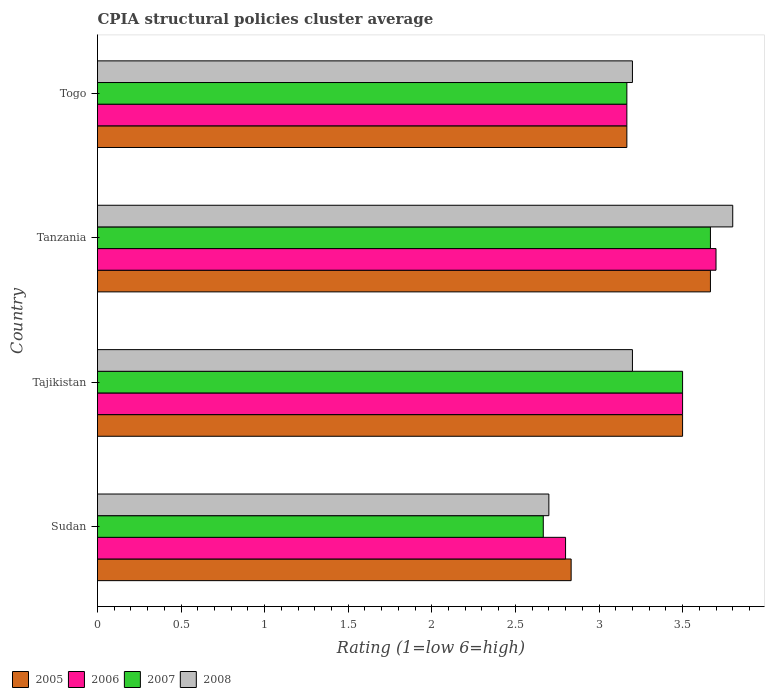How many groups of bars are there?
Ensure brevity in your answer.  4. Are the number of bars per tick equal to the number of legend labels?
Your answer should be compact. Yes. Are the number of bars on each tick of the Y-axis equal?
Your answer should be compact. Yes. What is the label of the 3rd group of bars from the top?
Provide a succinct answer. Tajikistan. In how many cases, is the number of bars for a given country not equal to the number of legend labels?
Offer a terse response. 0. Across all countries, what is the maximum CPIA rating in 2007?
Offer a terse response. 3.67. In which country was the CPIA rating in 2007 maximum?
Your answer should be compact. Tanzania. In which country was the CPIA rating in 2007 minimum?
Provide a succinct answer. Sudan. What is the total CPIA rating in 2007 in the graph?
Your answer should be very brief. 13. What is the difference between the CPIA rating in 2005 in Tajikistan and that in Tanzania?
Give a very brief answer. -0.17. What is the difference between the CPIA rating in 2008 in Togo and the CPIA rating in 2006 in Tajikistan?
Your answer should be very brief. -0.3. What is the average CPIA rating in 2008 per country?
Offer a very short reply. 3.22. What is the difference between the CPIA rating in 2006 and CPIA rating in 2008 in Sudan?
Offer a terse response. 0.1. What is the ratio of the CPIA rating in 2006 in Sudan to that in Togo?
Offer a very short reply. 0.88. Is the CPIA rating in 2008 in Sudan less than that in Tanzania?
Give a very brief answer. Yes. Is the difference between the CPIA rating in 2006 in Sudan and Tanzania greater than the difference between the CPIA rating in 2008 in Sudan and Tanzania?
Your answer should be very brief. Yes. What is the difference between the highest and the second highest CPIA rating in 2006?
Your answer should be very brief. 0.2. What is the difference between the highest and the lowest CPIA rating in 2008?
Your answer should be very brief. 1.1. Is it the case that in every country, the sum of the CPIA rating in 2008 and CPIA rating in 2007 is greater than the sum of CPIA rating in 2005 and CPIA rating in 2006?
Offer a terse response. No. What does the 1st bar from the bottom in Tanzania represents?
Your response must be concise. 2005. How many bars are there?
Your answer should be very brief. 16. Are all the bars in the graph horizontal?
Ensure brevity in your answer.  Yes. How many legend labels are there?
Offer a very short reply. 4. What is the title of the graph?
Ensure brevity in your answer.  CPIA structural policies cluster average. What is the label or title of the X-axis?
Your answer should be compact. Rating (1=low 6=high). What is the Rating (1=low 6=high) of 2005 in Sudan?
Make the answer very short. 2.83. What is the Rating (1=low 6=high) of 2006 in Sudan?
Offer a terse response. 2.8. What is the Rating (1=low 6=high) in 2007 in Sudan?
Provide a succinct answer. 2.67. What is the Rating (1=low 6=high) in 2005 in Tajikistan?
Provide a succinct answer. 3.5. What is the Rating (1=low 6=high) of 2006 in Tajikistan?
Offer a very short reply. 3.5. What is the Rating (1=low 6=high) of 2007 in Tajikistan?
Ensure brevity in your answer.  3.5. What is the Rating (1=low 6=high) of 2008 in Tajikistan?
Ensure brevity in your answer.  3.2. What is the Rating (1=low 6=high) of 2005 in Tanzania?
Make the answer very short. 3.67. What is the Rating (1=low 6=high) of 2007 in Tanzania?
Offer a very short reply. 3.67. What is the Rating (1=low 6=high) in 2005 in Togo?
Give a very brief answer. 3.17. What is the Rating (1=low 6=high) of 2006 in Togo?
Keep it short and to the point. 3.17. What is the Rating (1=low 6=high) in 2007 in Togo?
Your answer should be very brief. 3.17. Across all countries, what is the maximum Rating (1=low 6=high) in 2005?
Make the answer very short. 3.67. Across all countries, what is the maximum Rating (1=low 6=high) of 2007?
Keep it short and to the point. 3.67. Across all countries, what is the maximum Rating (1=low 6=high) of 2008?
Make the answer very short. 3.8. Across all countries, what is the minimum Rating (1=low 6=high) in 2005?
Provide a short and direct response. 2.83. Across all countries, what is the minimum Rating (1=low 6=high) in 2006?
Keep it short and to the point. 2.8. Across all countries, what is the minimum Rating (1=low 6=high) of 2007?
Provide a succinct answer. 2.67. What is the total Rating (1=low 6=high) of 2005 in the graph?
Provide a succinct answer. 13.17. What is the total Rating (1=low 6=high) in 2006 in the graph?
Your answer should be compact. 13.17. What is the total Rating (1=low 6=high) of 2007 in the graph?
Make the answer very short. 13. What is the difference between the Rating (1=low 6=high) of 2006 in Sudan and that in Tajikistan?
Make the answer very short. -0.7. What is the difference between the Rating (1=low 6=high) of 2007 in Sudan and that in Tajikistan?
Ensure brevity in your answer.  -0.83. What is the difference between the Rating (1=low 6=high) of 2005 in Sudan and that in Tanzania?
Your response must be concise. -0.83. What is the difference between the Rating (1=low 6=high) in 2007 in Sudan and that in Tanzania?
Offer a terse response. -1. What is the difference between the Rating (1=low 6=high) in 2006 in Sudan and that in Togo?
Ensure brevity in your answer.  -0.37. What is the difference between the Rating (1=low 6=high) of 2007 in Sudan and that in Togo?
Give a very brief answer. -0.5. What is the difference between the Rating (1=low 6=high) of 2005 in Tajikistan and that in Tanzania?
Your response must be concise. -0.17. What is the difference between the Rating (1=low 6=high) in 2006 in Tajikistan and that in Tanzania?
Your response must be concise. -0.2. What is the difference between the Rating (1=low 6=high) in 2007 in Tajikistan and that in Tanzania?
Your answer should be very brief. -0.17. What is the difference between the Rating (1=low 6=high) of 2005 in Tajikistan and that in Togo?
Your answer should be very brief. 0.33. What is the difference between the Rating (1=low 6=high) of 2007 in Tajikistan and that in Togo?
Keep it short and to the point. 0.33. What is the difference between the Rating (1=low 6=high) of 2008 in Tajikistan and that in Togo?
Keep it short and to the point. 0. What is the difference between the Rating (1=low 6=high) of 2006 in Tanzania and that in Togo?
Keep it short and to the point. 0.53. What is the difference between the Rating (1=low 6=high) of 2007 in Tanzania and that in Togo?
Your response must be concise. 0.5. What is the difference between the Rating (1=low 6=high) of 2008 in Tanzania and that in Togo?
Your answer should be very brief. 0.6. What is the difference between the Rating (1=low 6=high) of 2005 in Sudan and the Rating (1=low 6=high) of 2006 in Tajikistan?
Give a very brief answer. -0.67. What is the difference between the Rating (1=low 6=high) of 2005 in Sudan and the Rating (1=low 6=high) of 2007 in Tajikistan?
Your answer should be very brief. -0.67. What is the difference between the Rating (1=low 6=high) of 2005 in Sudan and the Rating (1=low 6=high) of 2008 in Tajikistan?
Keep it short and to the point. -0.37. What is the difference between the Rating (1=low 6=high) of 2006 in Sudan and the Rating (1=low 6=high) of 2008 in Tajikistan?
Your answer should be compact. -0.4. What is the difference between the Rating (1=low 6=high) of 2007 in Sudan and the Rating (1=low 6=high) of 2008 in Tajikistan?
Ensure brevity in your answer.  -0.53. What is the difference between the Rating (1=low 6=high) in 2005 in Sudan and the Rating (1=low 6=high) in 2006 in Tanzania?
Offer a terse response. -0.87. What is the difference between the Rating (1=low 6=high) in 2005 in Sudan and the Rating (1=low 6=high) in 2007 in Tanzania?
Provide a short and direct response. -0.83. What is the difference between the Rating (1=low 6=high) of 2005 in Sudan and the Rating (1=low 6=high) of 2008 in Tanzania?
Offer a very short reply. -0.97. What is the difference between the Rating (1=low 6=high) in 2006 in Sudan and the Rating (1=low 6=high) in 2007 in Tanzania?
Provide a short and direct response. -0.87. What is the difference between the Rating (1=low 6=high) of 2006 in Sudan and the Rating (1=low 6=high) of 2008 in Tanzania?
Ensure brevity in your answer.  -1. What is the difference between the Rating (1=low 6=high) of 2007 in Sudan and the Rating (1=low 6=high) of 2008 in Tanzania?
Your answer should be very brief. -1.13. What is the difference between the Rating (1=low 6=high) of 2005 in Sudan and the Rating (1=low 6=high) of 2007 in Togo?
Your answer should be very brief. -0.33. What is the difference between the Rating (1=low 6=high) in 2005 in Sudan and the Rating (1=low 6=high) in 2008 in Togo?
Ensure brevity in your answer.  -0.37. What is the difference between the Rating (1=low 6=high) of 2006 in Sudan and the Rating (1=low 6=high) of 2007 in Togo?
Give a very brief answer. -0.37. What is the difference between the Rating (1=low 6=high) of 2006 in Sudan and the Rating (1=low 6=high) of 2008 in Togo?
Make the answer very short. -0.4. What is the difference between the Rating (1=low 6=high) of 2007 in Sudan and the Rating (1=low 6=high) of 2008 in Togo?
Keep it short and to the point. -0.53. What is the difference between the Rating (1=low 6=high) in 2005 in Tajikistan and the Rating (1=low 6=high) in 2006 in Tanzania?
Offer a very short reply. -0.2. What is the difference between the Rating (1=low 6=high) of 2005 in Tajikistan and the Rating (1=low 6=high) of 2008 in Tanzania?
Ensure brevity in your answer.  -0.3. What is the difference between the Rating (1=low 6=high) in 2007 in Tajikistan and the Rating (1=low 6=high) in 2008 in Tanzania?
Provide a short and direct response. -0.3. What is the difference between the Rating (1=low 6=high) in 2006 in Tajikistan and the Rating (1=low 6=high) in 2008 in Togo?
Offer a very short reply. 0.3. What is the difference between the Rating (1=low 6=high) of 2005 in Tanzania and the Rating (1=low 6=high) of 2007 in Togo?
Your answer should be very brief. 0.5. What is the difference between the Rating (1=low 6=high) of 2005 in Tanzania and the Rating (1=low 6=high) of 2008 in Togo?
Keep it short and to the point. 0.47. What is the difference between the Rating (1=low 6=high) of 2006 in Tanzania and the Rating (1=low 6=high) of 2007 in Togo?
Your answer should be compact. 0.53. What is the difference between the Rating (1=low 6=high) of 2007 in Tanzania and the Rating (1=low 6=high) of 2008 in Togo?
Your response must be concise. 0.47. What is the average Rating (1=low 6=high) in 2005 per country?
Provide a short and direct response. 3.29. What is the average Rating (1=low 6=high) in 2006 per country?
Provide a short and direct response. 3.29. What is the average Rating (1=low 6=high) of 2007 per country?
Make the answer very short. 3.25. What is the average Rating (1=low 6=high) in 2008 per country?
Provide a succinct answer. 3.23. What is the difference between the Rating (1=low 6=high) in 2005 and Rating (1=low 6=high) in 2006 in Sudan?
Offer a very short reply. 0.03. What is the difference between the Rating (1=low 6=high) of 2005 and Rating (1=low 6=high) of 2007 in Sudan?
Provide a succinct answer. 0.17. What is the difference between the Rating (1=low 6=high) of 2005 and Rating (1=low 6=high) of 2008 in Sudan?
Keep it short and to the point. 0.13. What is the difference between the Rating (1=low 6=high) of 2006 and Rating (1=low 6=high) of 2007 in Sudan?
Offer a terse response. 0.13. What is the difference between the Rating (1=low 6=high) of 2007 and Rating (1=low 6=high) of 2008 in Sudan?
Make the answer very short. -0.03. What is the difference between the Rating (1=low 6=high) in 2006 and Rating (1=low 6=high) in 2007 in Tajikistan?
Your response must be concise. 0. What is the difference between the Rating (1=low 6=high) in 2006 and Rating (1=low 6=high) in 2008 in Tajikistan?
Offer a very short reply. 0.3. What is the difference between the Rating (1=low 6=high) in 2007 and Rating (1=low 6=high) in 2008 in Tajikistan?
Offer a terse response. 0.3. What is the difference between the Rating (1=low 6=high) in 2005 and Rating (1=low 6=high) in 2006 in Tanzania?
Your answer should be compact. -0.03. What is the difference between the Rating (1=low 6=high) in 2005 and Rating (1=low 6=high) in 2007 in Tanzania?
Provide a succinct answer. 0. What is the difference between the Rating (1=low 6=high) of 2005 and Rating (1=low 6=high) of 2008 in Tanzania?
Keep it short and to the point. -0.13. What is the difference between the Rating (1=low 6=high) in 2006 and Rating (1=low 6=high) in 2007 in Tanzania?
Give a very brief answer. 0.03. What is the difference between the Rating (1=low 6=high) in 2007 and Rating (1=low 6=high) in 2008 in Tanzania?
Your response must be concise. -0.13. What is the difference between the Rating (1=low 6=high) of 2005 and Rating (1=low 6=high) of 2006 in Togo?
Your answer should be very brief. 0. What is the difference between the Rating (1=low 6=high) in 2005 and Rating (1=low 6=high) in 2008 in Togo?
Provide a short and direct response. -0.03. What is the difference between the Rating (1=low 6=high) of 2006 and Rating (1=low 6=high) of 2008 in Togo?
Give a very brief answer. -0.03. What is the difference between the Rating (1=low 6=high) of 2007 and Rating (1=low 6=high) of 2008 in Togo?
Ensure brevity in your answer.  -0.03. What is the ratio of the Rating (1=low 6=high) of 2005 in Sudan to that in Tajikistan?
Your response must be concise. 0.81. What is the ratio of the Rating (1=low 6=high) of 2006 in Sudan to that in Tajikistan?
Provide a succinct answer. 0.8. What is the ratio of the Rating (1=low 6=high) of 2007 in Sudan to that in Tajikistan?
Provide a succinct answer. 0.76. What is the ratio of the Rating (1=low 6=high) of 2008 in Sudan to that in Tajikistan?
Your response must be concise. 0.84. What is the ratio of the Rating (1=low 6=high) of 2005 in Sudan to that in Tanzania?
Provide a succinct answer. 0.77. What is the ratio of the Rating (1=low 6=high) of 2006 in Sudan to that in Tanzania?
Provide a short and direct response. 0.76. What is the ratio of the Rating (1=low 6=high) in 2007 in Sudan to that in Tanzania?
Offer a very short reply. 0.73. What is the ratio of the Rating (1=low 6=high) of 2008 in Sudan to that in Tanzania?
Give a very brief answer. 0.71. What is the ratio of the Rating (1=low 6=high) in 2005 in Sudan to that in Togo?
Make the answer very short. 0.89. What is the ratio of the Rating (1=low 6=high) in 2006 in Sudan to that in Togo?
Your answer should be very brief. 0.88. What is the ratio of the Rating (1=low 6=high) of 2007 in Sudan to that in Togo?
Give a very brief answer. 0.84. What is the ratio of the Rating (1=low 6=high) in 2008 in Sudan to that in Togo?
Your answer should be compact. 0.84. What is the ratio of the Rating (1=low 6=high) of 2005 in Tajikistan to that in Tanzania?
Offer a terse response. 0.95. What is the ratio of the Rating (1=low 6=high) of 2006 in Tajikistan to that in Tanzania?
Give a very brief answer. 0.95. What is the ratio of the Rating (1=low 6=high) of 2007 in Tajikistan to that in Tanzania?
Ensure brevity in your answer.  0.95. What is the ratio of the Rating (1=low 6=high) in 2008 in Tajikistan to that in Tanzania?
Make the answer very short. 0.84. What is the ratio of the Rating (1=low 6=high) of 2005 in Tajikistan to that in Togo?
Offer a very short reply. 1.11. What is the ratio of the Rating (1=low 6=high) of 2006 in Tajikistan to that in Togo?
Give a very brief answer. 1.11. What is the ratio of the Rating (1=low 6=high) in 2007 in Tajikistan to that in Togo?
Your answer should be very brief. 1.11. What is the ratio of the Rating (1=low 6=high) of 2005 in Tanzania to that in Togo?
Ensure brevity in your answer.  1.16. What is the ratio of the Rating (1=low 6=high) in 2006 in Tanzania to that in Togo?
Your answer should be compact. 1.17. What is the ratio of the Rating (1=low 6=high) in 2007 in Tanzania to that in Togo?
Your response must be concise. 1.16. What is the ratio of the Rating (1=low 6=high) of 2008 in Tanzania to that in Togo?
Give a very brief answer. 1.19. What is the difference between the highest and the second highest Rating (1=low 6=high) in 2005?
Keep it short and to the point. 0.17. What is the difference between the highest and the lowest Rating (1=low 6=high) in 2006?
Offer a very short reply. 0.9. What is the difference between the highest and the lowest Rating (1=low 6=high) in 2007?
Your answer should be compact. 1. 